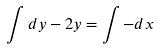Convert formula to latex. <formula><loc_0><loc_0><loc_500><loc_500>\int d y - 2 y = \int - d x</formula> 